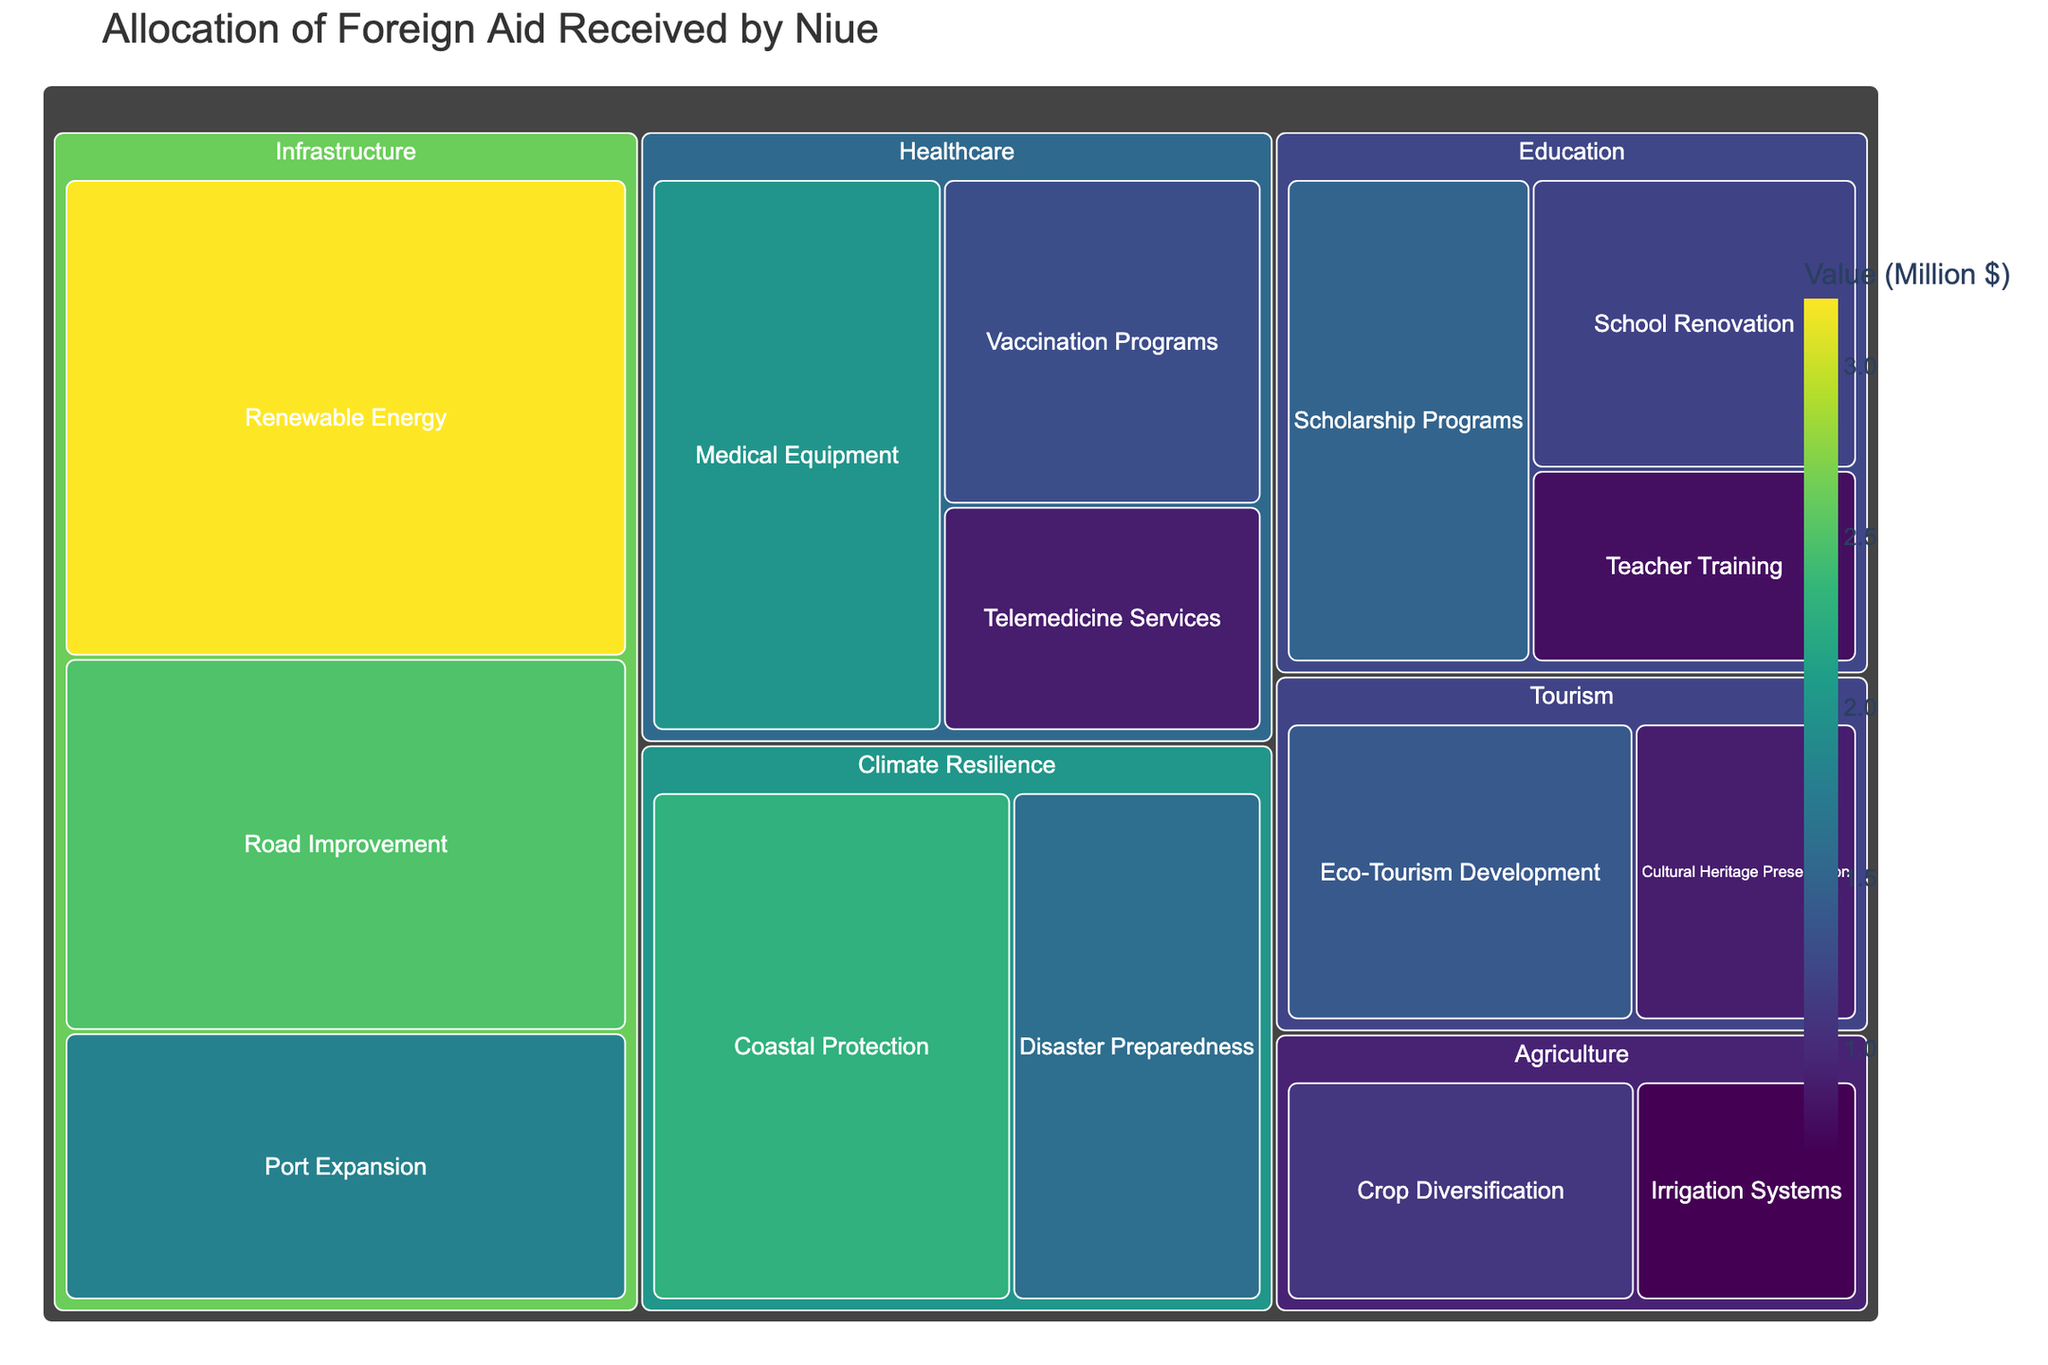What is the title of the treemap? The title is displayed prominently at the top of the treemap and provides a clear description of the subject. The title reads "Allocation of Foreign Aid Received by Niue."
Answer: Allocation of Foreign Aid Received by Niue How much foreign aid is allocated to Road Improvement in Infrastructure? To find the allocation for Road Improvement, locate the subcategory under Infrastructure and read the value. The value for Road Improvement is $2.5 million.
Answer: $2.5 million What is the largest single allocation of foreign aid, and which project category does it belong to? The largest allocation is identified by the largest segment in the treemap. The Renewable Energy project under the Infrastructure category has the highest value, which is $3.2 million.
Answer: $3.2 million, Infrastructure Which category has the smallest total allocation and what is the sum of its subcategories? By comparing the total values of each category, Agriculture has the smallest total allocation. Sum the values of Crop Diversification ($1.1M) and Irrigation Systems ($0.7M): $1.1M + $0.7M = $1.8M.
Answer: Agriculture, $1.8 million How does the allocation for Climate Resilience compare to the total allocation for Healthcare? First, sum the subcategories for Climate Resilience: Coastal Protection ($2.3M) + Disaster Preparedness ($1.6M) = $3.9M. Then, sum the subcategories for Healthcare: Medical Equipment ($2.0M) + Vaccination Programs ($1.3M) + Telemedicine Services ($0.9M) = $4.2M. Compare the totals: $3.9M (Climate Resilience) < $4.2M (Healthcare).
Answer: Healthcare has a larger allocation Which subcategory has the highest value in Education, and how does it compare to its lowest value subcategory? Identify the highest value subcategory in Education, which is Scholarship Programs ($1.5M). The lowest value subcategory is Teacher Training ($0.8M). Compare the values: $1.5M - $0.8M = $0.7M difference.
Answer: Scholarship Programs is higher by $0.7 million What is the average allocation for the subcategories in Tourism? Calculate the average by summing the values and dividing by the number of subcategories. For Tourism: ($1.4M + $0.9M) / 2 = $2.3M / 2 = $1.15M.
Answer: $1.15 million 